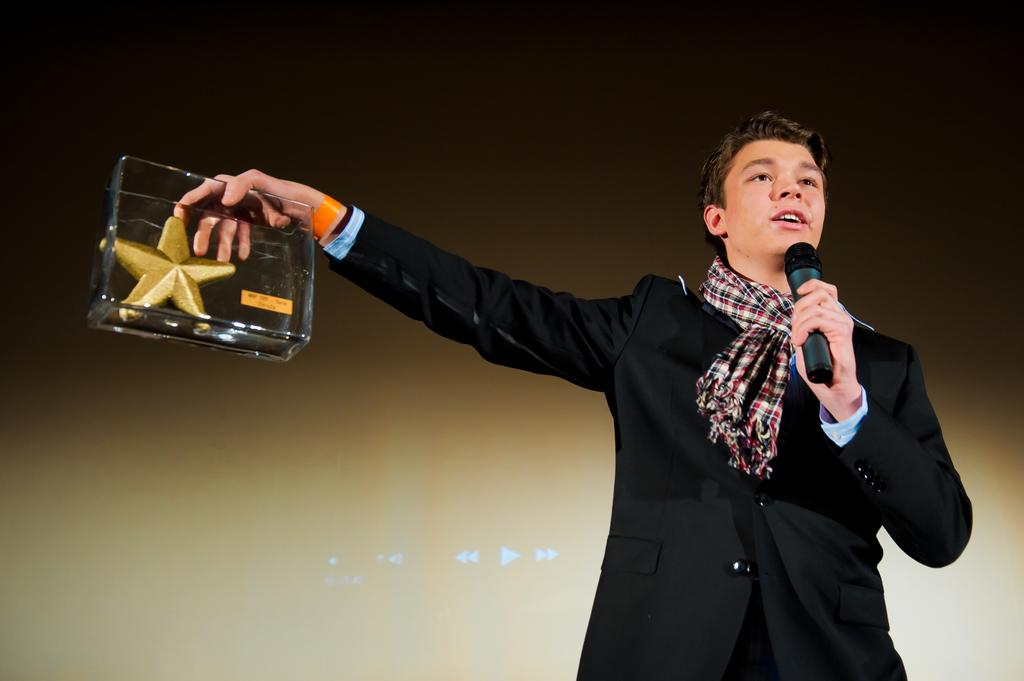What is the man doing on the right side of the image? The man is standing on the right side of the image and holding a mic. What else is the man holding in the image? The man is holding a box with a golden starfish in his hands. What can be seen in the background of the image? There is a screen in the background of the image. Can you tell me how many friends the man has in the image? There is no information about friends in the image; it only shows the man holding a mic and a box with a golden starfish. Are there any dinosaurs present in the image? No, there are no dinosaurs present in the image. 